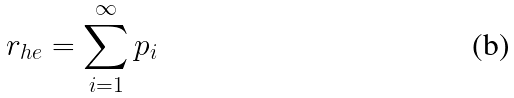<formula> <loc_0><loc_0><loc_500><loc_500>r _ { h e } = \sum _ { i = 1 } ^ { \infty } p _ { i }</formula> 